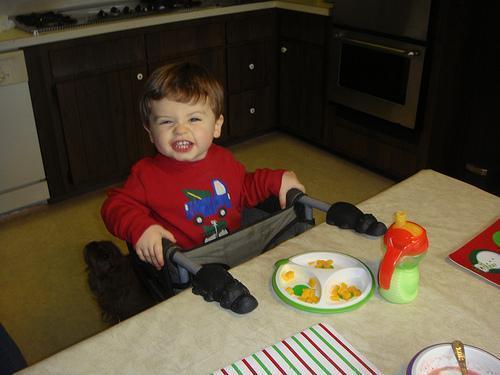How many placemats do you see?
Give a very brief answer. 2. How many children do you see in the picture?
Give a very brief answer. 1. 